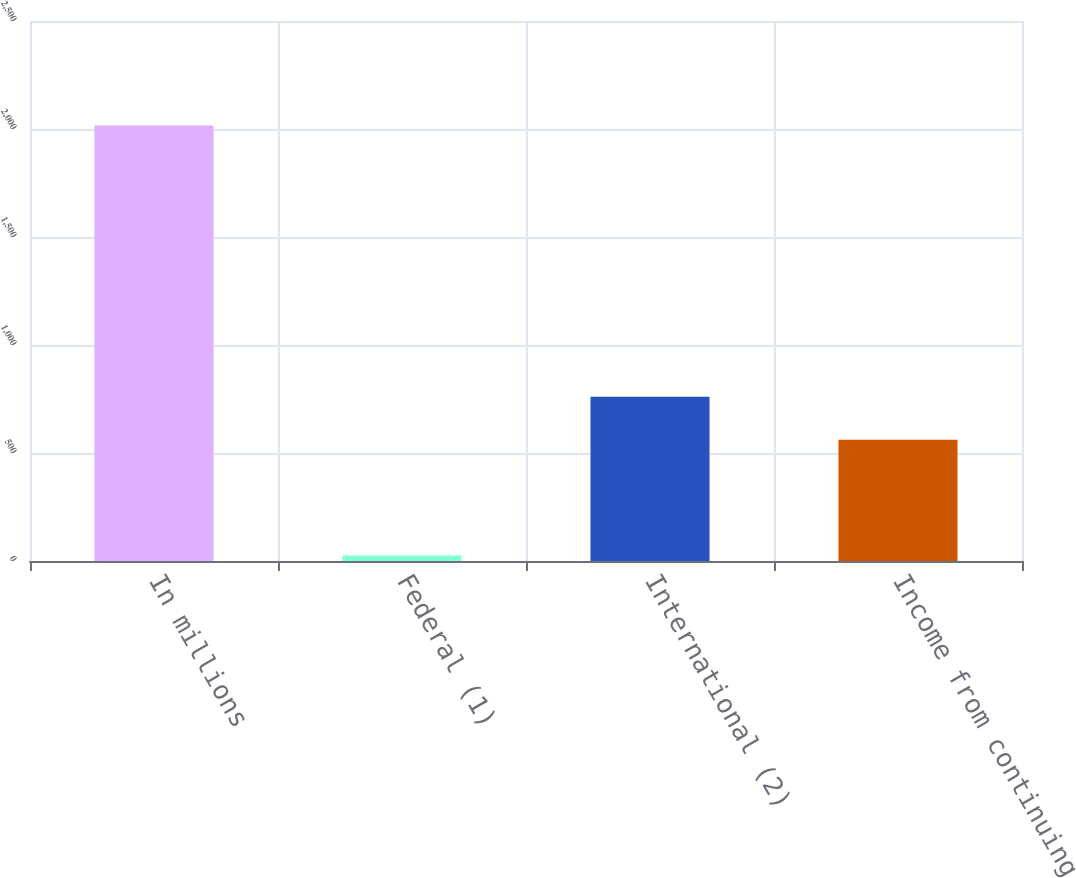Convert chart. <chart><loc_0><loc_0><loc_500><loc_500><bar_chart><fcel>In millions<fcel>Federal (1)<fcel>International (2)<fcel>Income from continuing<nl><fcel>2016<fcel>25.6<fcel>760.04<fcel>561<nl></chart> 